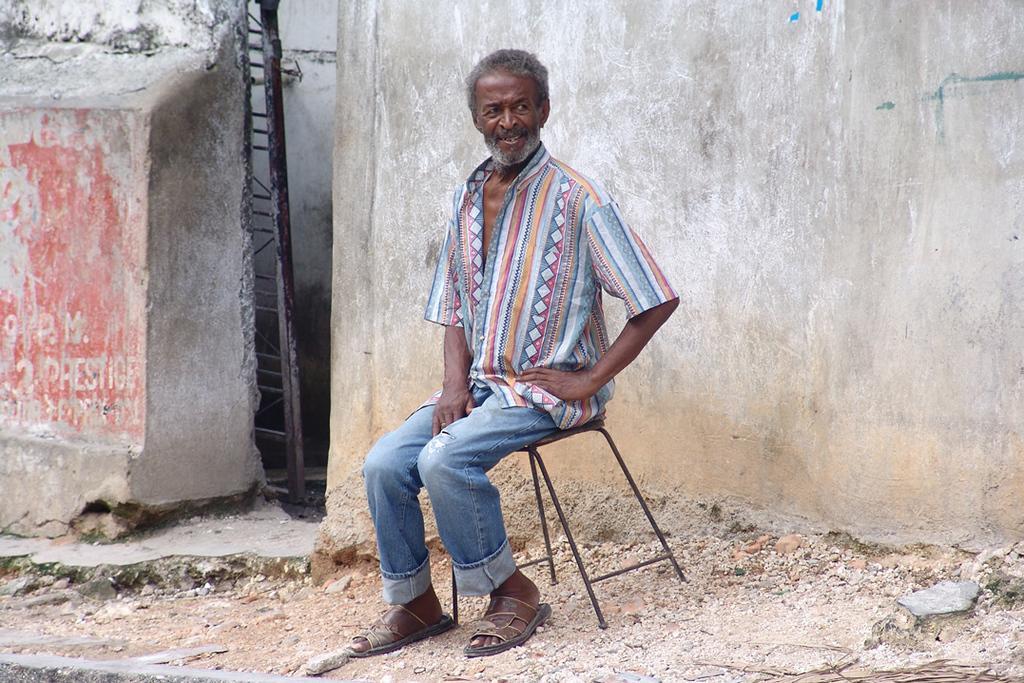Could you give a brief overview of what you see in this image? In this image there is a person sitting on the stool,and in the background there is a gate ,wall. 